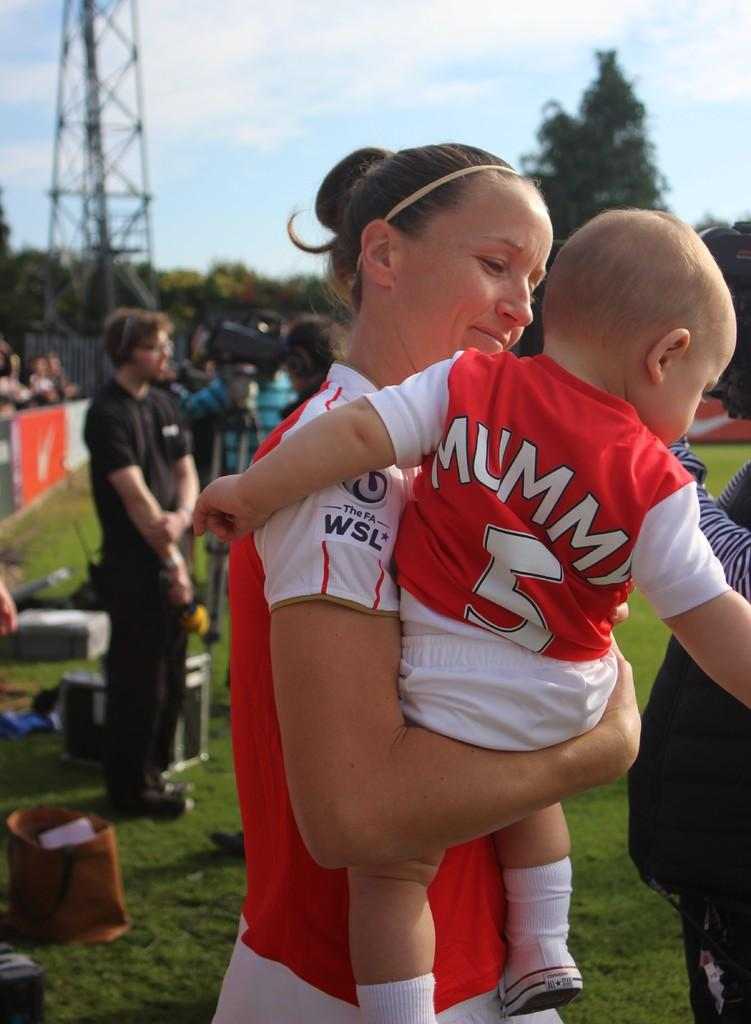<image>
Present a compact description of the photo's key features. A woman holding a baby with the words Mummy 5 on his shirt. 